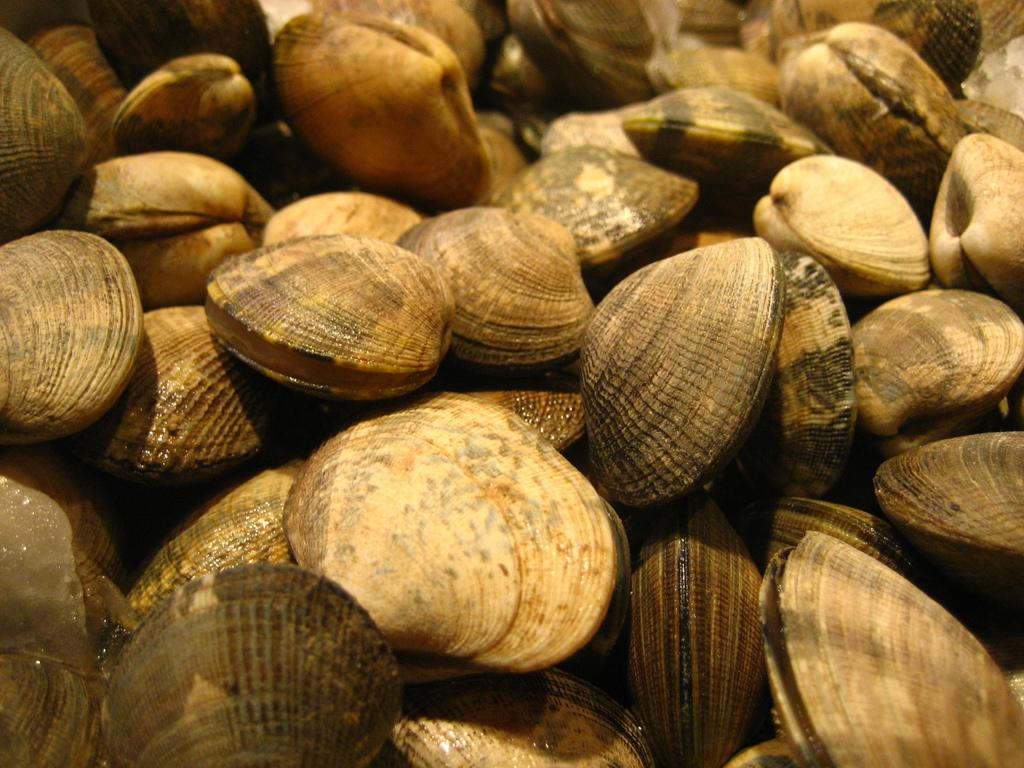What type of seafood is present in the image? There are clams in the image. How many laborers are working in the plantation depicted in the image? There is no plantation or laborers present in the image; it only features clams. What type of chair is visible in the image? There is no chair present in the image; it only features clams. 